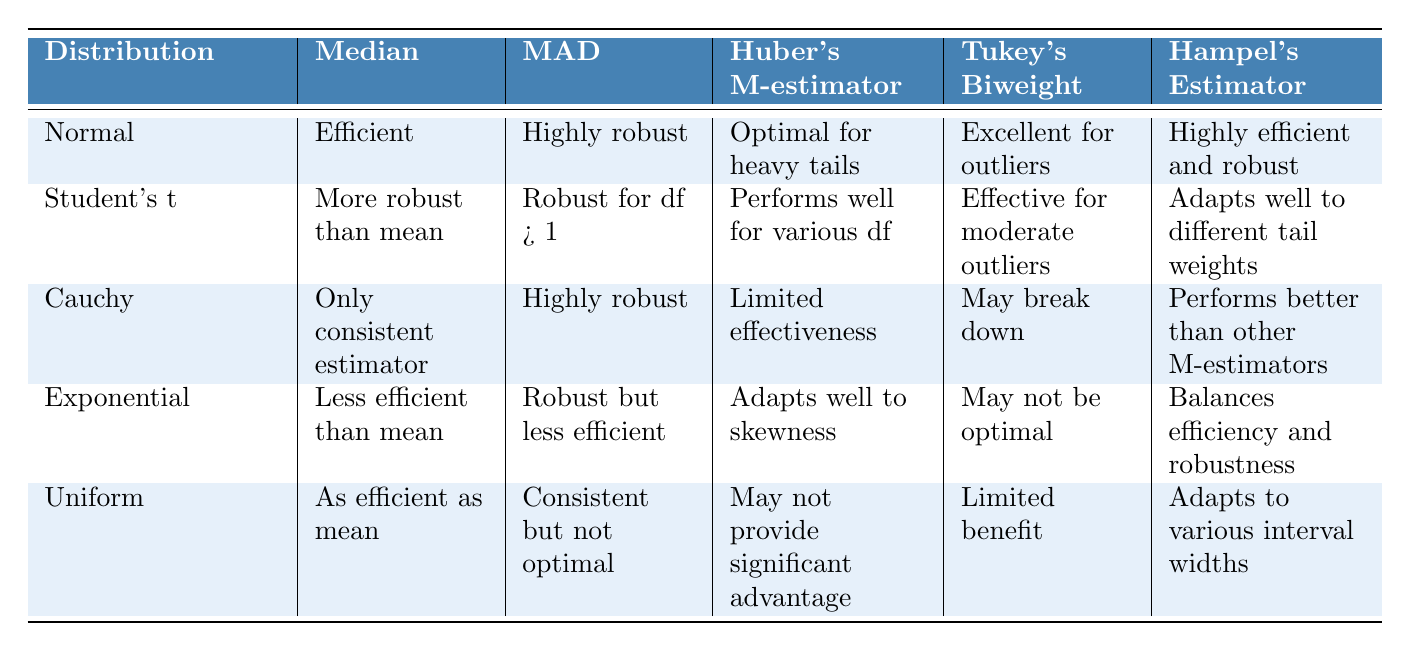What is the robustness level of the Median Absolute Deviation (MAD) for Cauchy Distribution? The table shows that the Median Absolute Deviation for Cauchy Distribution is labeled as "Highly robust." Thus, it indicates a significant level of robustness despite the nature of the distribution.
Answer: Highly robust Which distribution has the optimal performance for Huber's M-estimator? According to the table, Normal Distribution is specified as "Optimal for heavy tails" when it comes to Huber's M-estimator. Thus, it performs the best in the context listed.
Answer: Normal Distribution Does the Uniform Distribution's Hampel's Estimator provide a significant advantage? The table states that for Uniform Distribution, Huber's M-estimator "May not provide significant advantage", indicating that it doesn't stand out in effectiveness compared to others.
Answer: No Which distribution shows the least efficiency regarding its median compared to the mean? The Exponential Distribution is indicated as "Less efficient than mean" in the table, which highlights that its median does not perform as well relative to the mean.
Answer: Exponential Distribution For which distribution is Tukey's Biweight stated to be effective for moderate outliers? The table shows that Tukey's Biweight is particularly stated as "Effective for moderate outliers" in relation to Student's t-Distribution, making this distribution notable for this robustness measure.
Answer: Student's t-Distribution How does the Median for the Cauchy Distribution compare with that of other distributions? The table indicates that the Cauchy Distribution has "Only consistent estimator" as its median, which is unique since other distributions show varying degrees of efficiency or robustness.
Answer: Only consistent estimator What is the median classification for the Exponential Distribution? According to the table, the Exponential Distribution's median is classified as "Less efficient than mean," which provides an understanding of its relative effectiveness in comparison to the mean.
Answer: Less efficient than mean Which distribution has a median that is as efficient as the mean? The Uniform Distribution is noted as having a median that is "As efficient as mean," indicating it performs on par with the mean in this context.
Answer: Uniform Distribution What does Huber's M-estimator characterize for the Cauchy Distribution? The table outlines that Huber's M-estimator has "Limited effectiveness" for the Cauchy Distribution, suggesting challenges in its application for this specific distribution.
Answer: Limited effectiveness Which distribution adapts well to skewness regarding Huber's M-estimator? The table highlights that the Exponential Distribution has an advantageous characteristic by stating that Huber's M-estimator "Adapts well to skewness." Hence, this distribution is suited to handle skewed data.
Answer: Exponential Distribution 